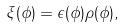Convert formula to latex. <formula><loc_0><loc_0><loc_500><loc_500>\xi ( \phi ) = \epsilon ( \phi ) \rho ( \phi ) ,</formula> 